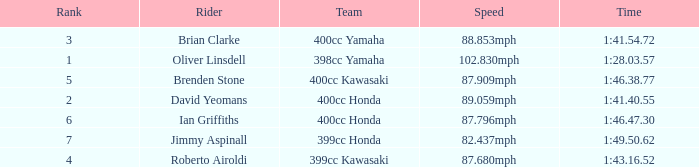Who is the rider with a 399cc Kawasaki? Roberto Airoldi. 